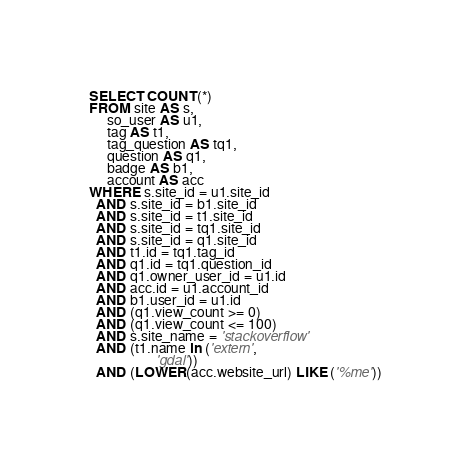<code> <loc_0><loc_0><loc_500><loc_500><_SQL_>SELECT COUNT(*)
FROM site AS s,
     so_user AS u1,
     tag AS t1,
     tag_question AS tq1,
     question AS q1,
     badge AS b1,
     account AS acc
WHERE s.site_id = u1.site_id
  AND s.site_id = b1.site_id
  AND s.site_id = t1.site_id
  AND s.site_id = tq1.site_id
  AND s.site_id = q1.site_id
  AND t1.id = tq1.tag_id
  AND q1.id = tq1.question_id
  AND q1.owner_user_id = u1.id
  AND acc.id = u1.account_id
  AND b1.user_id = u1.id
  AND (q1.view_count >= 0)
  AND (q1.view_count <= 100)
  AND s.site_name = 'stackoverflow'
  AND (t1.name in ('extern',
                   'gdal'))
  AND (LOWER(acc.website_url) LIKE ('%me'))</code> 